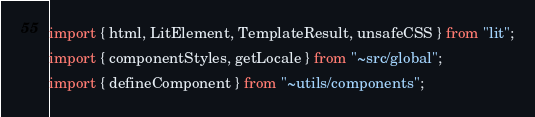Convert code to text. <code><loc_0><loc_0><loc_500><loc_500><_TypeScript_>import { html, LitElement, TemplateResult, unsafeCSS } from "lit";
import { componentStyles, getLocale } from "~src/global";
import { defineComponent } from "~utils/components";</code> 